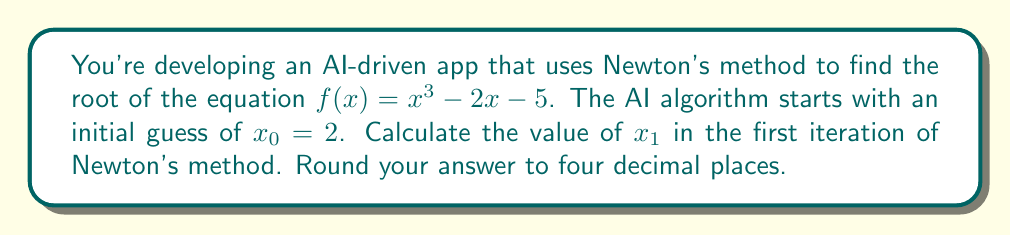Help me with this question. Let's apply Newton's method to solve this problem:

1. Newton's method formula:
   $$x_{n+1} = x_n - \frac{f(x_n)}{f'(x_n)}$$

2. Given function:
   $$f(x) = x^3 - 2x - 5$$

3. Calculate the derivative:
   $$f'(x) = 3x^2 - 2$$

4. For the first iteration, we use $x_0 = 2$:

   Calculate $f(x_0)$:
   $$f(2) = 2^3 - 2(2) - 5 = 8 - 4 - 5 = -1$$

   Calculate $f'(x_0)$:
   $$f'(2) = 3(2)^2 - 2 = 3(4) - 2 = 12 - 2 = 10$$

5. Apply Newton's method formula:
   $$x_1 = x_0 - \frac{f(x_0)}{f'(x_0)} = 2 - \frac{-1}{10} = 2 + 0.1 = 2.1$$

6. Round to four decimal places:
   $$x_1 \approx 2.1000$$
Answer: 2.1000 